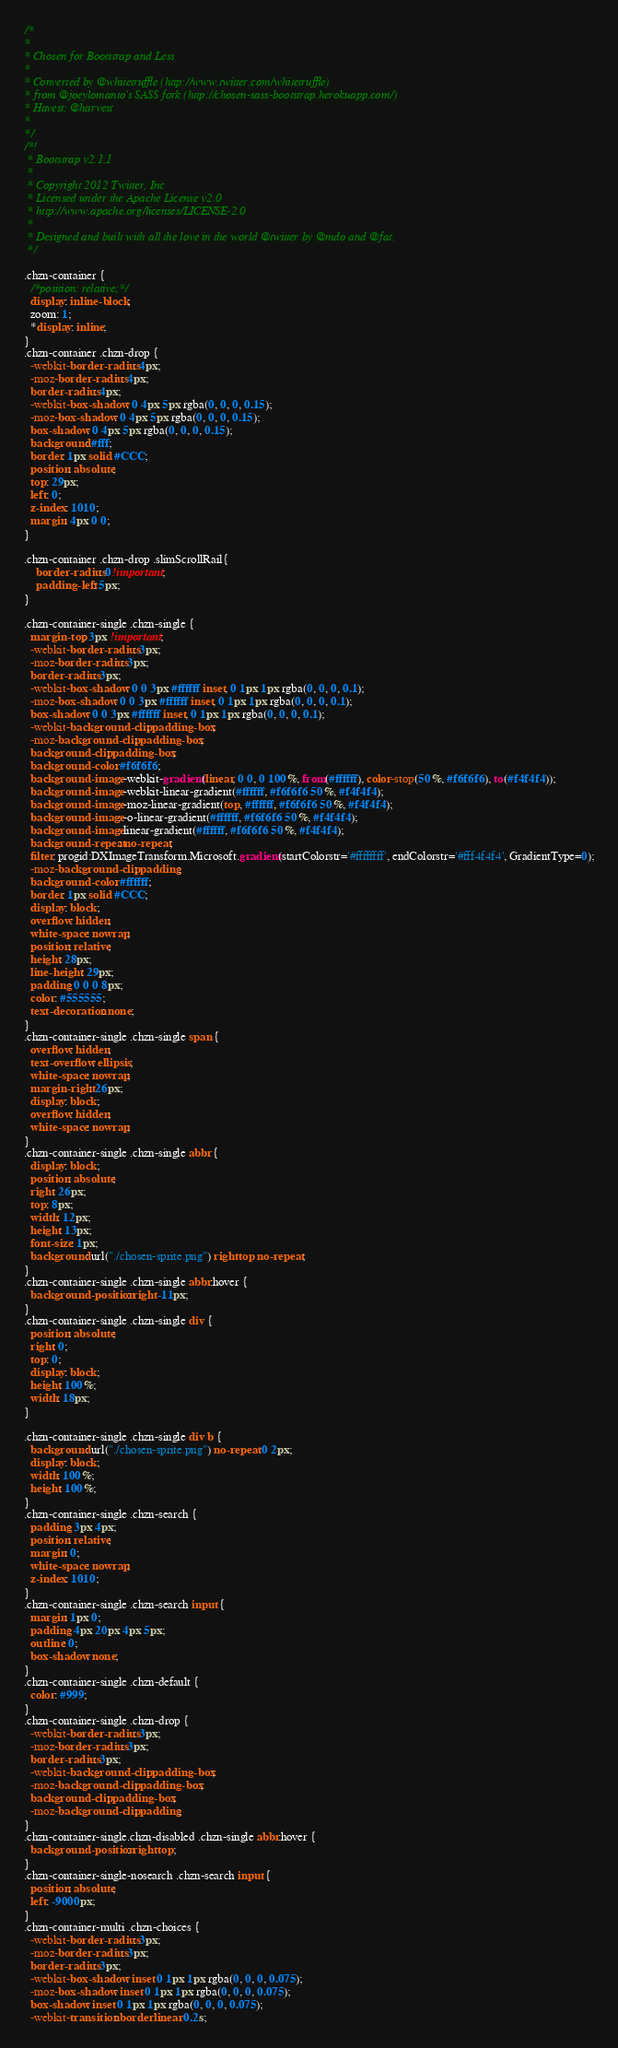<code> <loc_0><loc_0><loc_500><loc_500><_CSS_>/*
*
* Chosen for Bootstrap and Less
*
* Converted by @whitetruffle (http://www.twitter.com/whitetruffle)
* from @joeylomanto's SASS fork (http://chosen-sass-bootstrap.herokuapp.com/)
* Havest: @harvest
*
*/
/*!
 * Bootstrap v2.1.1
 *
 * Copyright 2012 Twitter, Inc
 * Licensed under the Apache License v2.0
 * http://www.apache.org/licenses/LICENSE-2.0
 *
 * Designed and built with all the love in the world @twitter by @mdo and @fat.
 */

.chzn-container {
  /*position: relative;*/
  display: inline-block;
  zoom: 1;
  *display: inline;
}
.chzn-container .chzn-drop {
  -webkit-border-radius: 4px;
  -moz-border-radius: 4px;
  border-radius: 4px;
  -webkit-box-shadow: 0 4px 5px rgba(0, 0, 0, 0.15);
  -moz-box-shadow: 0 4px 5px rgba(0, 0, 0, 0.15);
  box-shadow: 0 4px 5px rgba(0, 0, 0, 0.15);
  background: #fff;
  border: 1px solid #CCC;
  position: absolute;
  top: 29px;
  left: 0;
  z-index: 1010;
  margin: 4px 0 0;
}

.chzn-container .chzn-drop .slimScrollRail{
    border-radius: 0!important;
    padding-left: 5px;
}

.chzn-container-single .chzn-single {
  margin-top: 3px !important;
  -webkit-border-radius: 3px;
  -moz-border-radius: 3px;
  border-radius: 3px;
  -webkit-box-shadow: 0 0 3px #ffffff inset, 0 1px 1px rgba(0, 0, 0, 0.1);
  -moz-box-shadow: 0 0 3px #ffffff inset, 0 1px 1px rgba(0, 0, 0, 0.1);
  box-shadow: 0 0 3px #ffffff inset, 0 1px 1px rgba(0, 0, 0, 0.1);
  -webkit-background-clip: padding-box;
  -moz-background-clip: padding-box;
  background-clip: padding-box;
  background-color: #f6f6f6;
  background-image: -webkit-gradient(linear, 0 0, 0 100%, from(#ffffff), color-stop(50%, #f6f6f6), to(#f4f4f4));
  background-image: -webkit-linear-gradient(#ffffff, #f6f6f6 50%, #f4f4f4);
  background-image: -moz-linear-gradient(top, #ffffff, #f6f6f6 50%, #f4f4f4);
  background-image: -o-linear-gradient(#ffffff, #f6f6f6 50%, #f4f4f4);
  background-image: linear-gradient(#ffffff, #f6f6f6 50%, #f4f4f4);
  background-repeat: no-repeat;
  filter: progid:DXImageTransform.Microsoft.gradient(startColorstr='#ffffffff', endColorstr='#fff4f4f4', GradientType=0);
  -moz-background-clip: padding;
  background-color: #ffffff;
  border: 1px solid #CCC;
  display: block;
  overflow: hidden;
  white-space: nowrap;
  position: relative;
  height: 28px;
  line-height: 29px;
  padding: 0 0 0 8px;
  color: #555555;
  text-decoration: none;
}
.chzn-container-single .chzn-single span {
  overflow: hidden;
  text-overflow: ellipsis;
  white-space: nowrap;
  margin-right: 26px;
  display: block;
  overflow: hidden;
  white-space: nowrap;
}
.chzn-container-single .chzn-single abbr {
  display: block;
  position: absolute;
  right: 26px;
  top: 8px;
  width: 12px;
  height: 13px;
  font-size: 1px;
  background: url("./chosen-sprite.png") right top no-repeat;
}
.chzn-container-single .chzn-single abbr:hover {
  background-position: right -11px;
}
.chzn-container-single .chzn-single div {
  position: absolute;
  right: 0;
  top: 0;
  display: block;
  height: 100%;
  width: 18px;
}

.chzn-container-single .chzn-single div b {
  background: url("./chosen-sprite.png") no-repeat 0 2px;
  display: block;
  width: 100%;
  height: 100%;
}
.chzn-container-single .chzn-search {
  padding: 3px 4px;
  position: relative;
  margin: 0;
  white-space: nowrap;
  z-index: 1010;
}
.chzn-container-single .chzn-search input {
  margin: 1px 0;
  padding: 4px 20px 4px 5px;
  outline: 0;
  box-shadow: none;
}
.chzn-container-single .chzn-default {
  color: #999;
}
.chzn-container-single .chzn-drop {
  -webkit-border-radius: 3px;
  -moz-border-radius: 3px;
  border-radius: 3px;
  -webkit-background-clip: padding-box;
  -moz-background-clip: padding-box;
  background-clip: padding-box;
  -moz-background-clip: padding;
}
.chzn-container-single.chzn-disabled .chzn-single abbr:hover {
  background-position: right top;
}
.chzn-container-single-nosearch .chzn-search input {
  position: absolute;
  left: -9000px;
}
.chzn-container-multi .chzn-choices {
  -webkit-border-radius: 3px;
  -moz-border-radius: 3px;
  border-radius: 3px;
  -webkit-box-shadow: inset 0 1px 1px rgba(0, 0, 0, 0.075);
  -moz-box-shadow: inset 0 1px 1px rgba(0, 0, 0, 0.075);
  box-shadow: inset 0 1px 1px rgba(0, 0, 0, 0.075);
  -webkit-transition: border linear 0.2s;</code> 